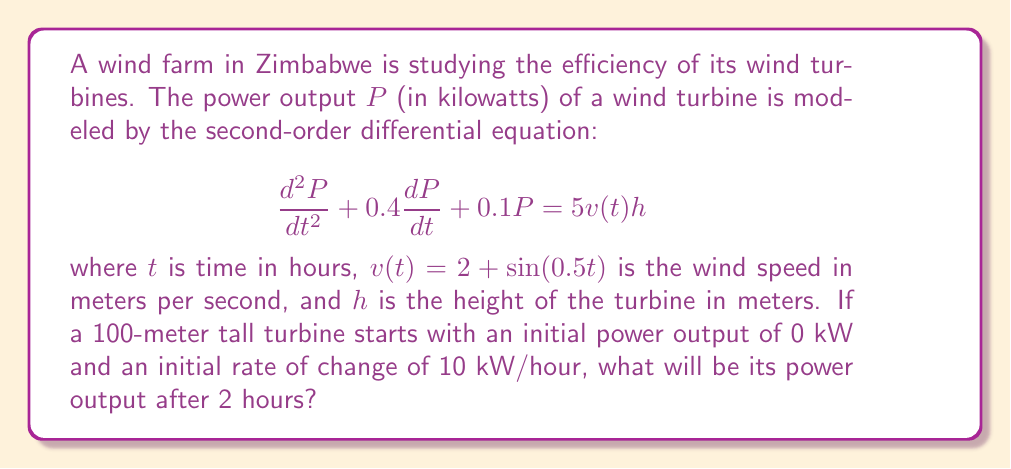Provide a solution to this math problem. To solve this problem, we need to follow these steps:

1) First, we need to solve the differential equation. The general solution for a second-order linear differential equation of the form:

   $$\frac{d^2y}{dt^2} + a\frac{dy}{dt} + by = f(t)$$

   is the sum of the complementary function (solution to the homogeneous equation) and a particular integral.

2) The characteristic equation is:
   
   $$r^2 + 0.4r + 0.1 = 0$$

   Solving this gives us: $r_1 = -0.2 + 0.2i$ and $r_2 = -0.2 - 0.2i$

3) Therefore, the complementary function is:

   $$P_c = e^{-0.2t}(A\cos(0.2t) + B\sin(0.2t))$$

4) For the particular integral, we need to solve:

   $$\frac{d^2P_p}{dt^2} + 0.4\frac{dP_p}{dt} + 0.1P_p = 5(2 + \sin(0.5t))h$$

   A particular solution will be of the form:

   $$P_p = C + D\sin(0.5t) + E\cos(0.5t)$$

5) Substituting this into the original equation and equating coefficients, we get:

   $$C = 100h, D = \frac{12.5h}{0.41}, E = -\frac{5h}{0.41}$$

6) The general solution is thus:

   $$P = e^{-0.2t}(A\cos(0.2t) + B\sin(0.2t)) + 100h + \frac{12.5h}{0.41}\sin(0.5t) - \frac{5h}{0.41}\cos(0.5t)$$

7) Using the initial conditions $P(0) = 0$ and $P'(0) = 10$, we can solve for A and B:

   $$A = -100h + \frac{5h}{0.41} \approx -112.2h$$
   $$B = -50h - \frac{6.25h}{0.41} + \frac{1h}{0.41} \approx -65.3h$$

8) Substituting $h = 100$ and $t = 2$ into our solution:

   $$P(2) = e^{-0.4}(-11220\cos(0.4) - 6530\sin(0.4)) + 10000 + 3048.8\sin(1) - 1219.5\cos(1)$$

9) Calculating this gives us the final answer.
Answer: The power output after 2 hours will be approximately 13,580 kW. 